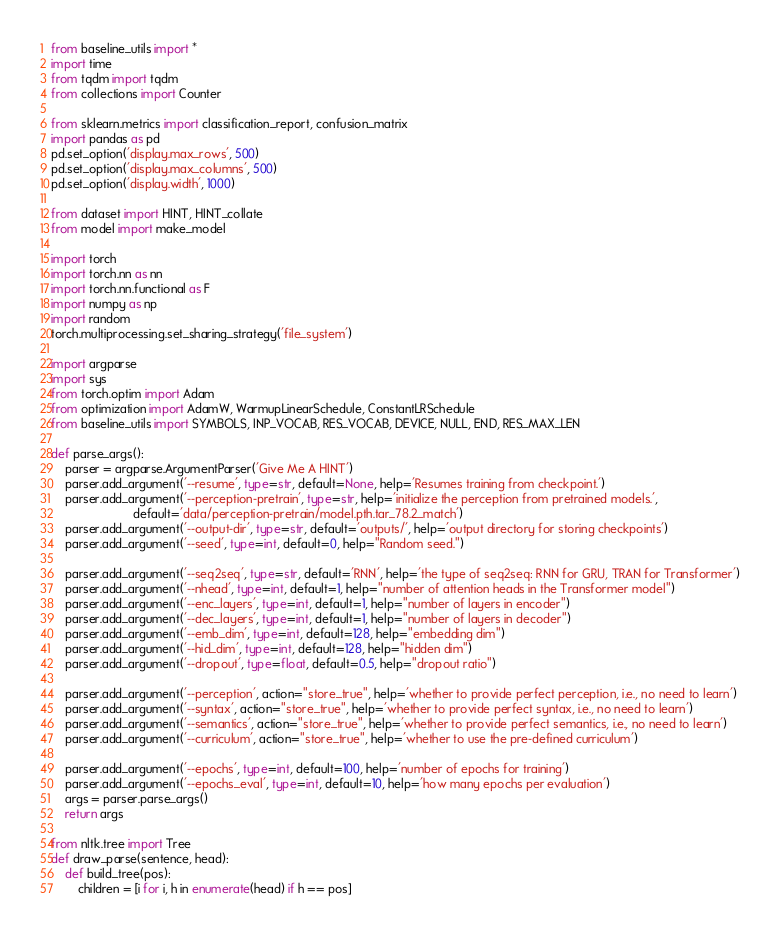Convert code to text. <code><loc_0><loc_0><loc_500><loc_500><_Python_>from baseline_utils import *
import time
from tqdm import tqdm
from collections import Counter

from sklearn.metrics import classification_report, confusion_matrix
import pandas as pd
pd.set_option('display.max_rows', 500)
pd.set_option('display.max_columns', 500)
pd.set_option('display.width', 1000)

from dataset import HINT, HINT_collate
from model import make_model

import torch
import torch.nn as nn
import torch.nn.functional as F
import numpy as np
import random
torch.multiprocessing.set_sharing_strategy('file_system')

import argparse
import sys
from torch.optim import Adam
from optimization import AdamW, WarmupLinearSchedule, ConstantLRSchedule
from baseline_utils import SYMBOLS, INP_VOCAB, RES_VOCAB, DEVICE, NULL, END, RES_MAX_LEN

def parse_args():
    parser = argparse.ArgumentParser('Give Me A HINT')
    parser.add_argument('--resume', type=str, default=None, help='Resumes training from checkpoint.')
    parser.add_argument('--perception-pretrain', type=str, help='initialize the perception from pretrained models.',
                        default='data/perception-pretrain/model.pth.tar_78.2_match')
    parser.add_argument('--output-dir', type=str, default='outputs/', help='output directory for storing checkpoints')
    parser.add_argument('--seed', type=int, default=0, help="Random seed.")

    parser.add_argument('--seq2seq', type=str, default='RNN', help='the type of seq2seq: RNN for GRU, TRAN for Transformer')
    parser.add_argument('--nhead', type=int, default=1, help="number of attention heads in the Transformer model")
    parser.add_argument('--enc_layers', type=int, default=1, help="number of layers in encoder")
    parser.add_argument('--dec_layers', type=int, default=1, help="number of layers in decoder")
    parser.add_argument('--emb_dim', type=int, default=128, help="embedding dim")
    parser.add_argument('--hid_dim', type=int, default=128, help="hidden dim")
    parser.add_argument('--dropout', type=float, default=0.5, help="dropout ratio")

    parser.add_argument('--perception', action="store_true", help='whether to provide perfect perception, i.e., no need to learn')
    parser.add_argument('--syntax', action="store_true", help='whether to provide perfect syntax, i.e., no need to learn')
    parser.add_argument('--semantics', action="store_true", help='whether to provide perfect semantics, i.e., no need to learn')
    parser.add_argument('--curriculum', action="store_true", help='whether to use the pre-defined curriculum')

    parser.add_argument('--epochs', type=int, default=100, help='number of epochs for training')
    parser.add_argument('--epochs_eval', type=int, default=10, help='how many epochs per evaluation')
    args = parser.parse_args()
    return args

from nltk.tree import Tree
def draw_parse(sentence, head):
    def build_tree(pos):
        children = [i for i, h in enumerate(head) if h == pos]</code> 